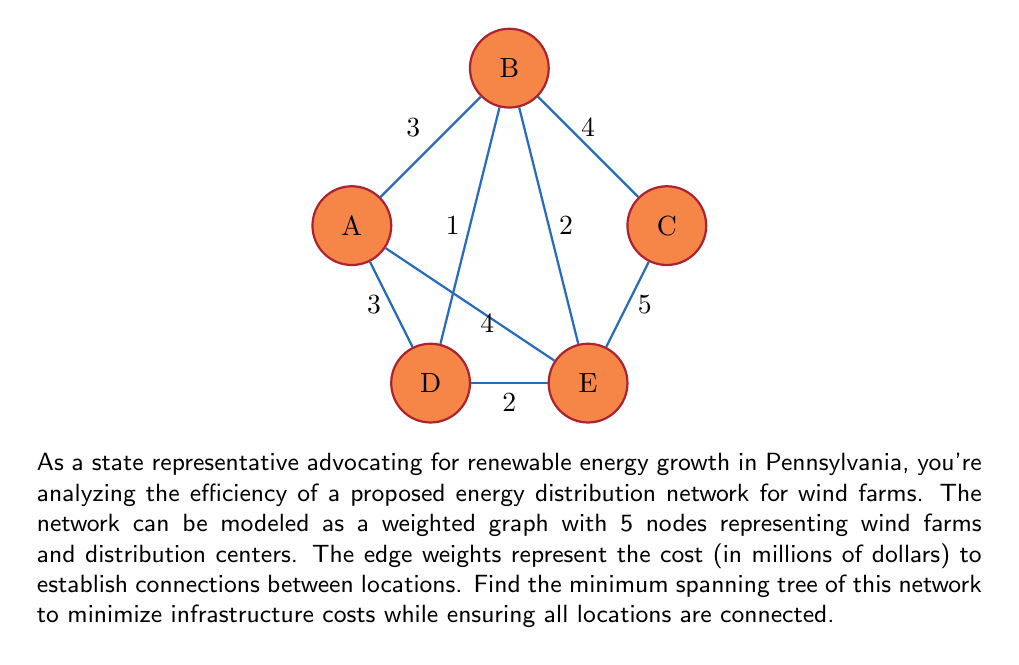Solve this math problem. To find the minimum spanning tree, we can use Kruskal's algorithm:

1) Sort the edges by weight in ascending order:
   B-D (1), D-E (2), B-E (2), A-B (3), A-D (3), B-C (4), A-E (4), C-E (5)

2) Start with an empty set of edges and add edges in order, skipping those that would create a cycle:

   - Add B-D (1)
   - Add D-E (2)
   - Add A-B (3)
   - Skip B-E (2) as it would create a cycle
   - Add B-C (4)

3) We now have 4 edges connecting all 5 nodes, so we're done.

The minimum spanning tree consists of edges:
B-D (1), D-E (2), A-B (3), B-C (4)

The total cost of this network is:

$$1 + 2 + 3 + 4 = 10$$ million dollars

This represents the most cost-effective way to connect all wind farms and distribution centers in the network.
Answer: Minimum spanning tree: B-D, D-E, A-B, B-C; Total cost: $10 million 